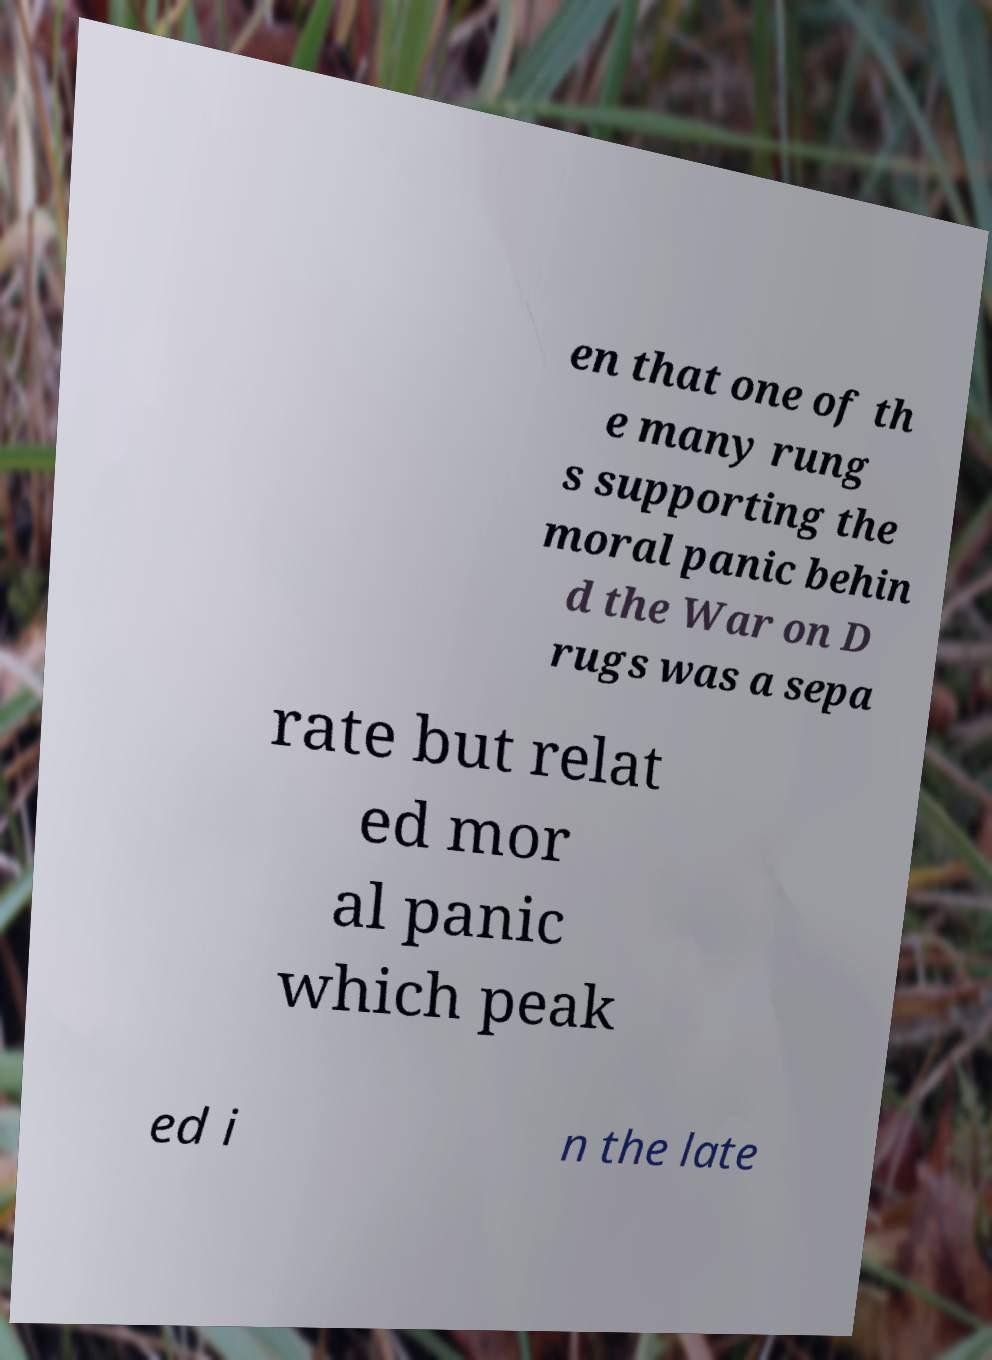I need the written content from this picture converted into text. Can you do that? en that one of th e many rung s supporting the moral panic behin d the War on D rugs was a sepa rate but relat ed mor al panic which peak ed i n the late 